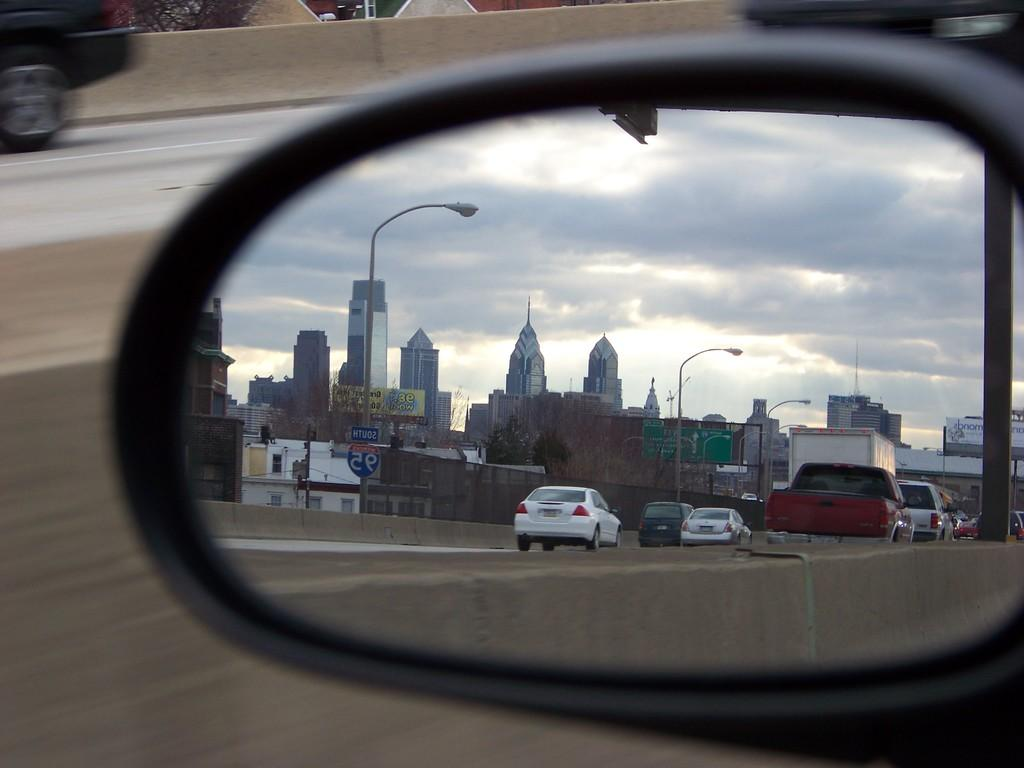What is the main subject of the image? The main subject of the image is the side mirror of a vehicle. What can be seen in the side mirror? Cars are visible in the side mirror. What are the cars doing in the image? The cars are moving on the road. What is visible in the background of the image? There are buildings and clouds in the sky in the background of the image. What type of beam is being used to taste the clouds in the image? There is no beam or tasting of clouds in the image; it only shows a side mirror with cars moving on the road, buildings, and clouds in the background. 